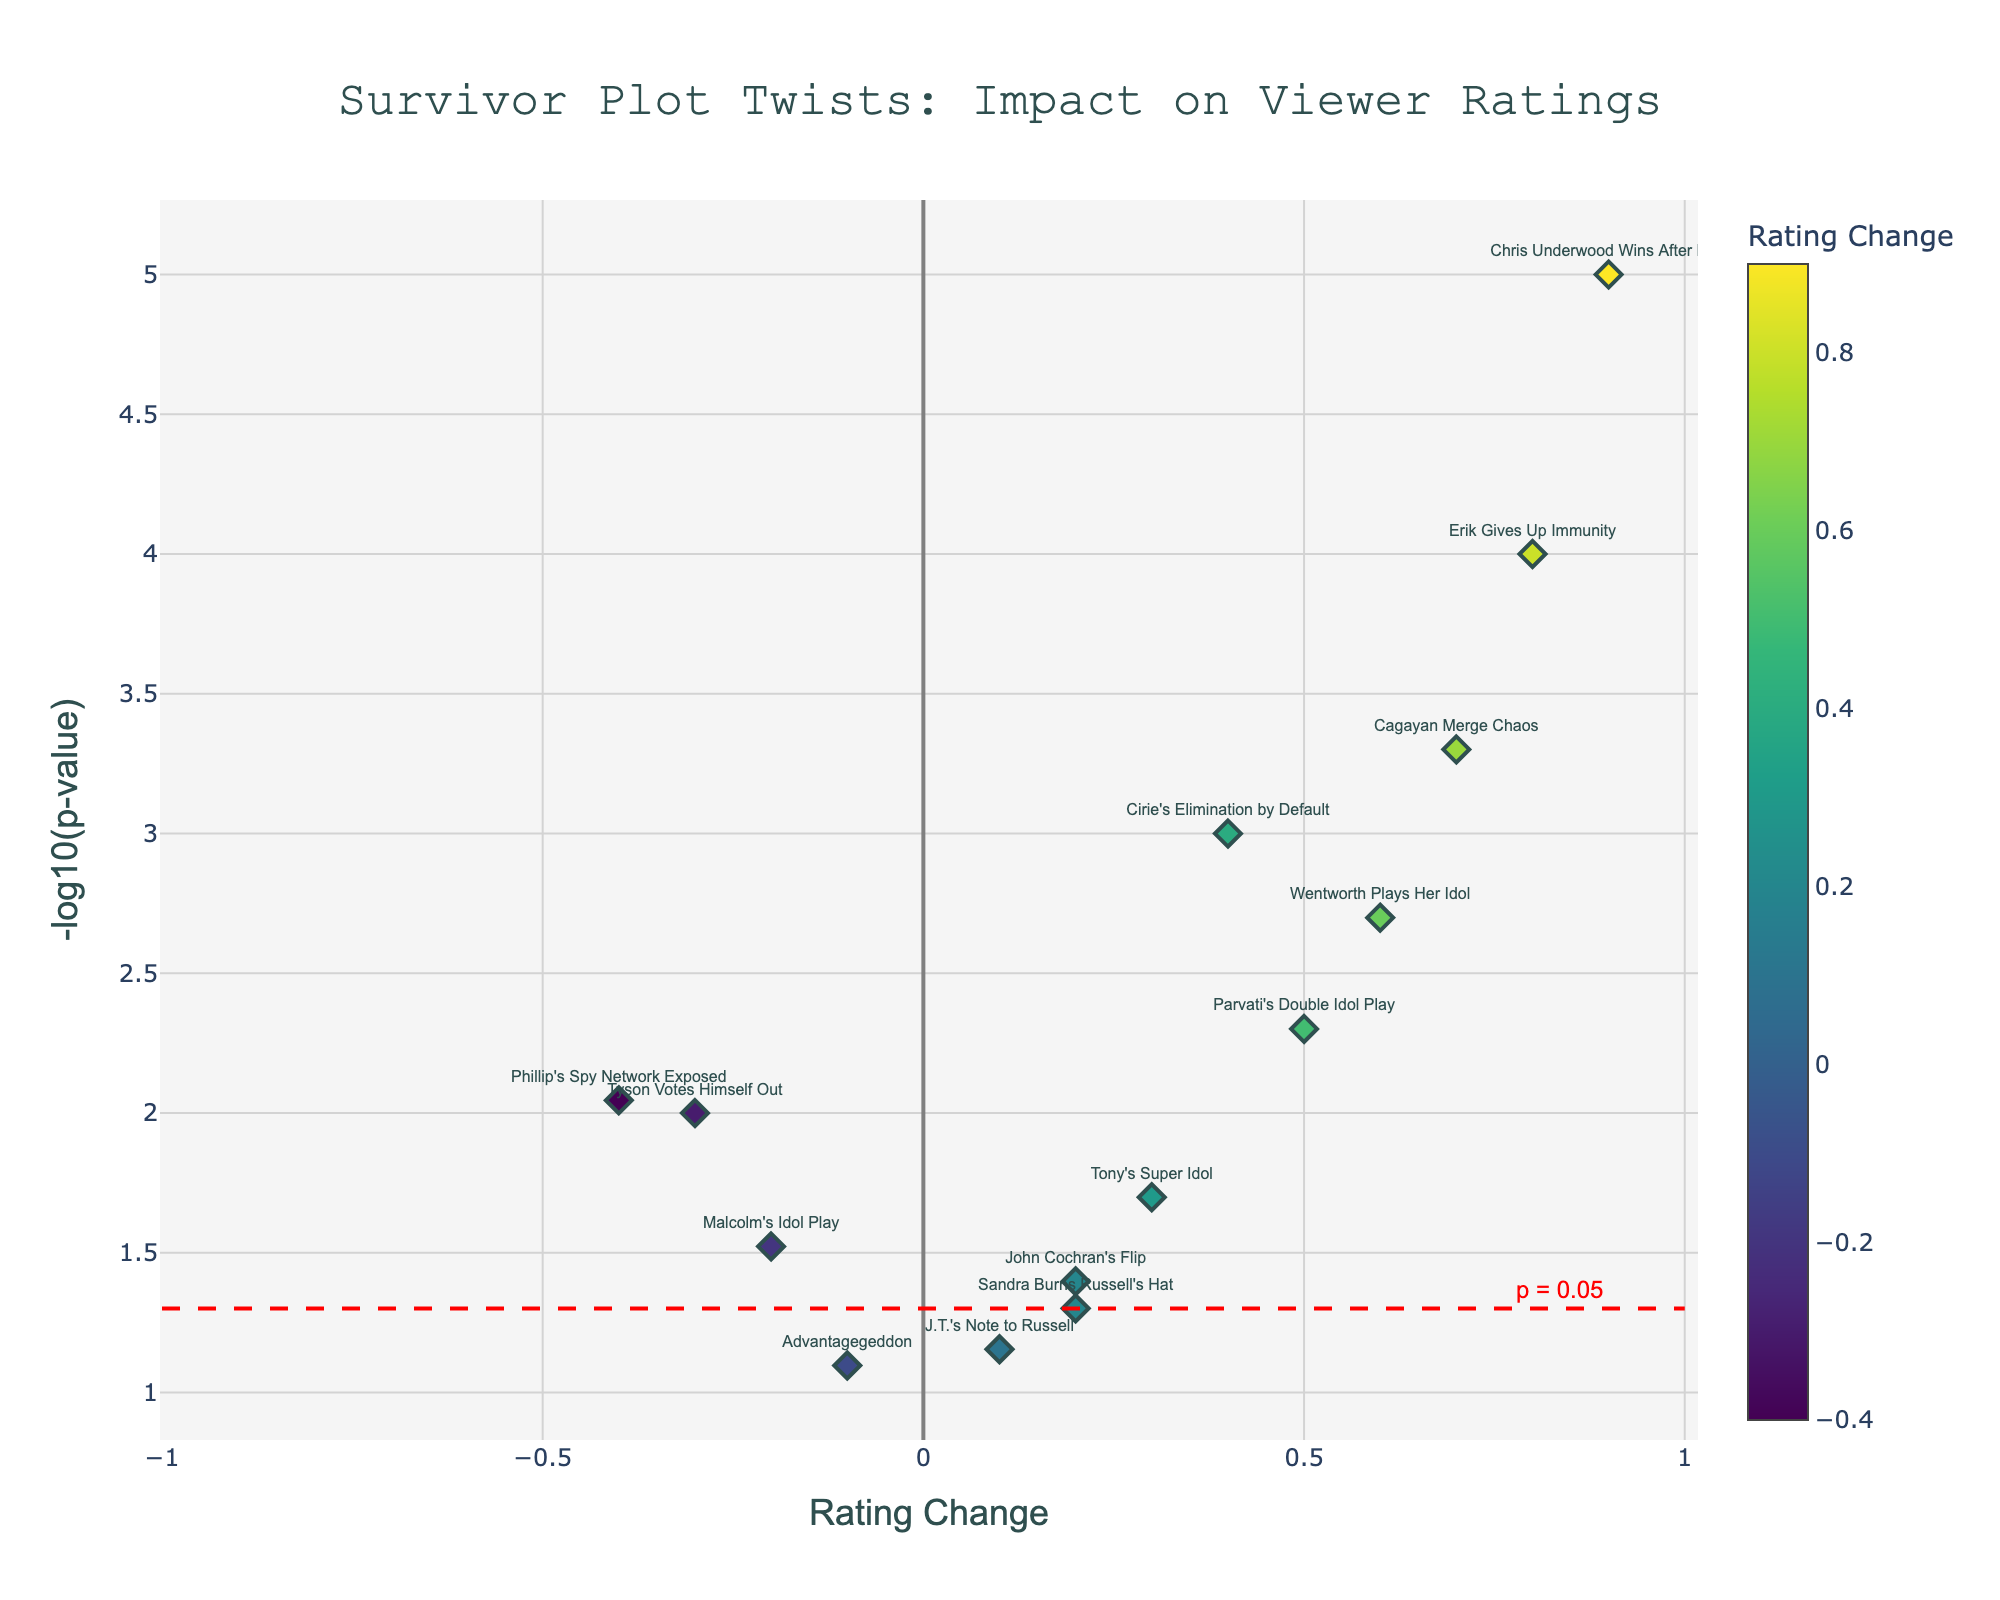What is the title of the plot? The title of the plot is usually displayed at the top center of the figure. For this volcano plot, the title is clearly visible.
Answer: Survivor Plot Twists: Impact on Viewer Ratings What do the axes represent? The x-axis represents the Rating Change, while the y-axis represents the -log10(p-value). These values are essential for interpreting the viewer rating fluctuations and their statistical significance.
Answer: Rating Change and -log10(p-value) Which episode had the highest increase in viewer ratings? By examining the plot, we identify the episode with the highest point along the x-axis in the positive direction. It corresponds to "Chris Underwood Wins After EoE".
Answer: Chris Underwood Wins After EoE How many episodes had a statistically significant impact on viewer ratings? An episode is considered statistically significant if it is above the significance threshold line (red dashed line at -log10(p-value) of 0.05). Count the number of data points above this line.
Answer: 10 Which episode had the most negative impact on viewer ratings? The episode with the most negative impact is the one with the lowest point along the x-axis in the negative direction. It corresponds to "Phillip's Spy Network Exposed".
Answer: Phillip's Spy Network Exposed Which episodes fall below the significance threshold line? The plots below the red dashed line (-log10(p-value) of 0.05) are labeled as "Advantagegeddon" and "J.T.'s Note to Russell".
Answer: Advantagegeddon and J.T.'s Note to Russell What is the y-axis value for an episode with a p-value of 0.005? Using the formula -log10(p-value): -log10(0.005) = 2.301. The y-axis value for a p-value of 0.005 is approximately 2.301.
Answer: 2.301 Compare the rating changes of "Parvati's Double Idol Play" and "Malcolm's Idol Play". Which one had a greater impact? "Parvati's Double Idol Play" had a rating change of 0.5 while "Malcolm's Idol Play" had a rating change of -0.2. Observing these values, "Parvati's Double Idol Play" had a greater positive impact.
Answer: Parvati's Double Idol Play Which episode had the second highest -log10(p-value) value? "Chris Underwood Wins After EoE" has the highest -log10(p-value). The second highest, just below it, is "Erik Gives Up Immunity".
Answer: Erik Gives Up Immunity 